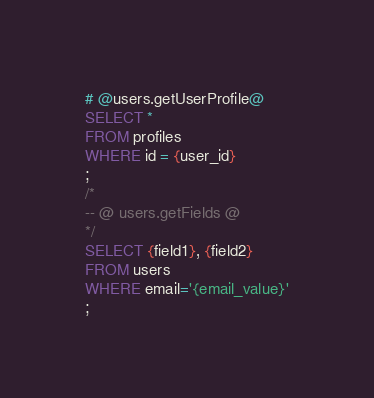Convert code to text. <code><loc_0><loc_0><loc_500><loc_500><_SQL_># @users.getUserProfile@
SELECT *
FROM profiles
WHERE id = {user_id}
;
/*
-- @ users.getFields @
*/
SELECT {field1}, {field2}
FROM users
WHERE email='{email_value}'
;</code> 